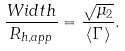Convert formula to latex. <formula><loc_0><loc_0><loc_500><loc_500>\frac { W i d t h } { R _ { h , a p p } } = \frac { \sqrt { \mu _ { 2 } } } { \left \langle \Gamma \right \rangle } .</formula> 